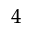<formula> <loc_0><loc_0><loc_500><loc_500>^ { 4 }</formula> 